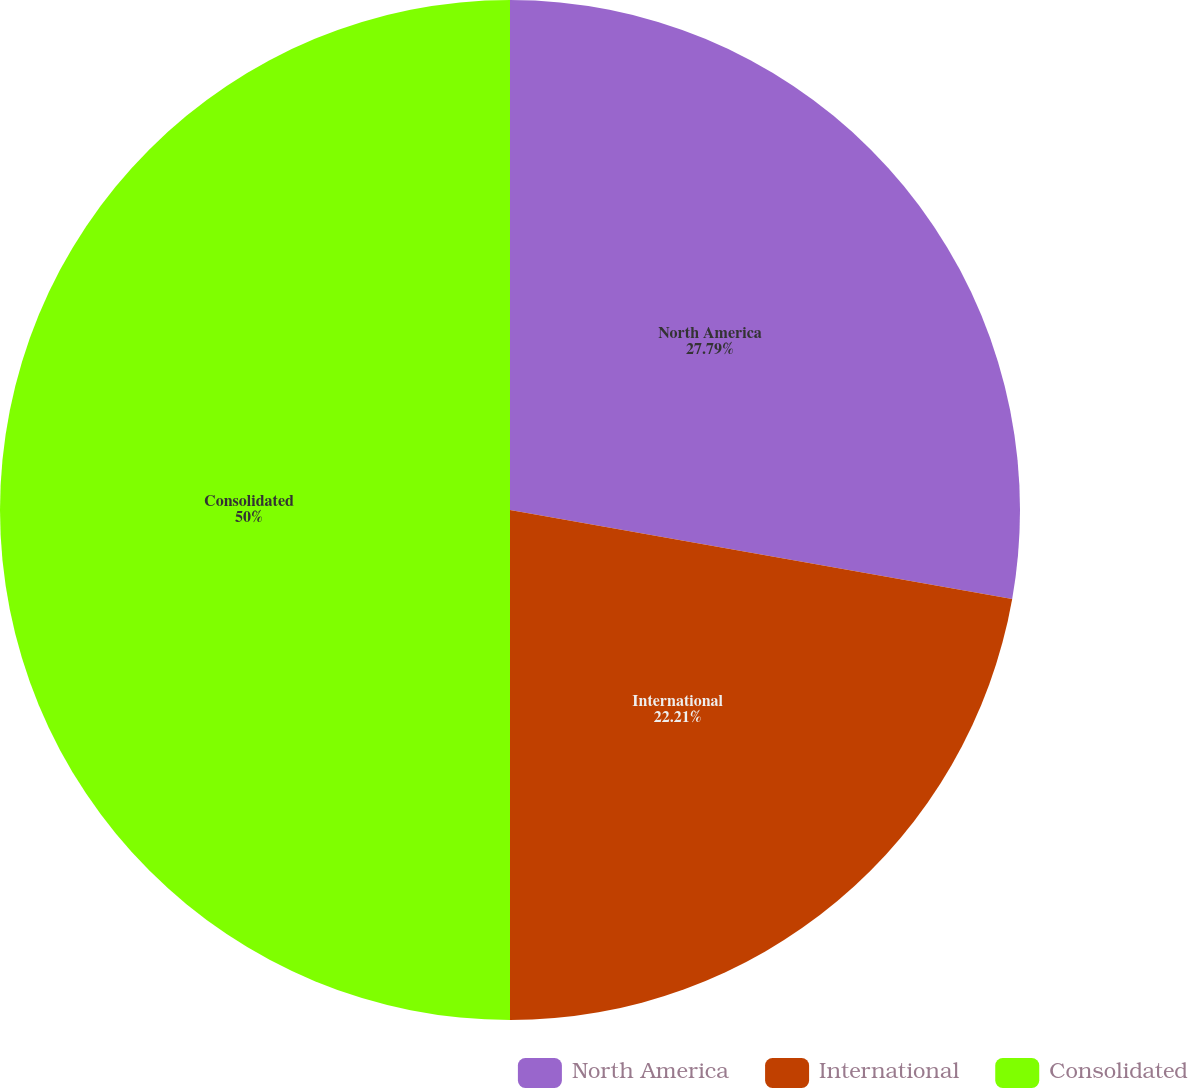Convert chart. <chart><loc_0><loc_0><loc_500><loc_500><pie_chart><fcel>North America<fcel>International<fcel>Consolidated<nl><fcel>27.79%<fcel>22.21%<fcel>50.0%<nl></chart> 